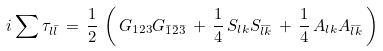<formula> <loc_0><loc_0><loc_500><loc_500>i \sum \tau _ { l \bar { l } } \, = \, \frac { 1 } { 2 } \, \left ( \, G _ { 1 2 3 } G _ { \bar { 1 } \bar { 2 } \bar { 3 } } \, + \, \frac { 1 } { 4 } \, S _ { l k } S _ { \bar { l } \bar { k } } \, + \, \frac { 1 } { 4 } \, A _ { l k } A _ { \bar { l } \bar { k } } \, \right )</formula> 